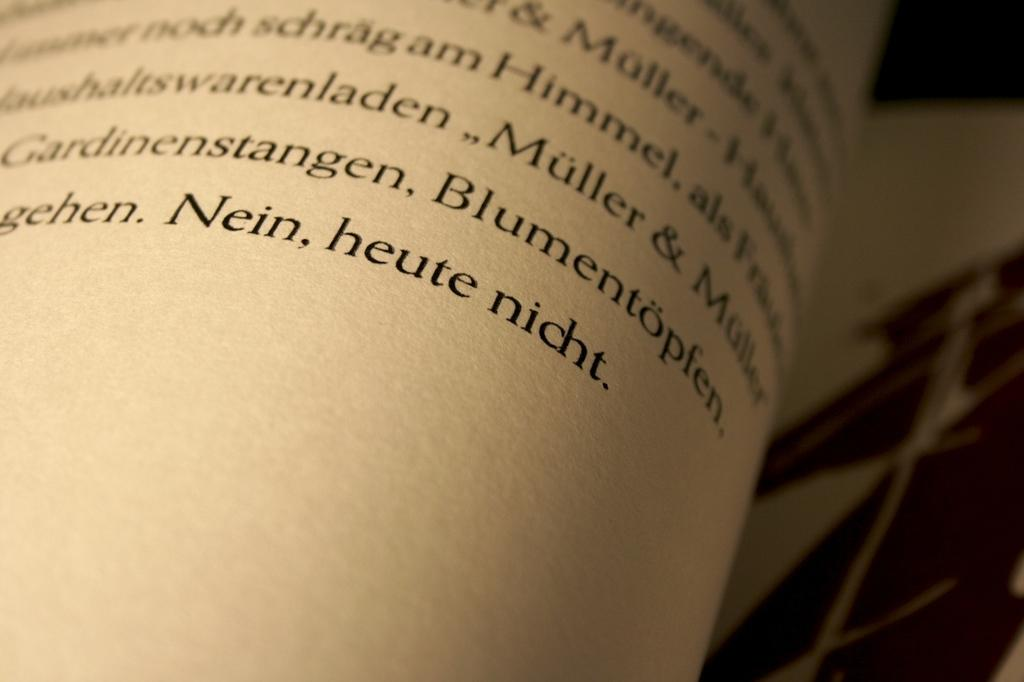<image>
Give a short and clear explanation of the subsequent image. Looking at a book in foreign language with a magnifying glass. 